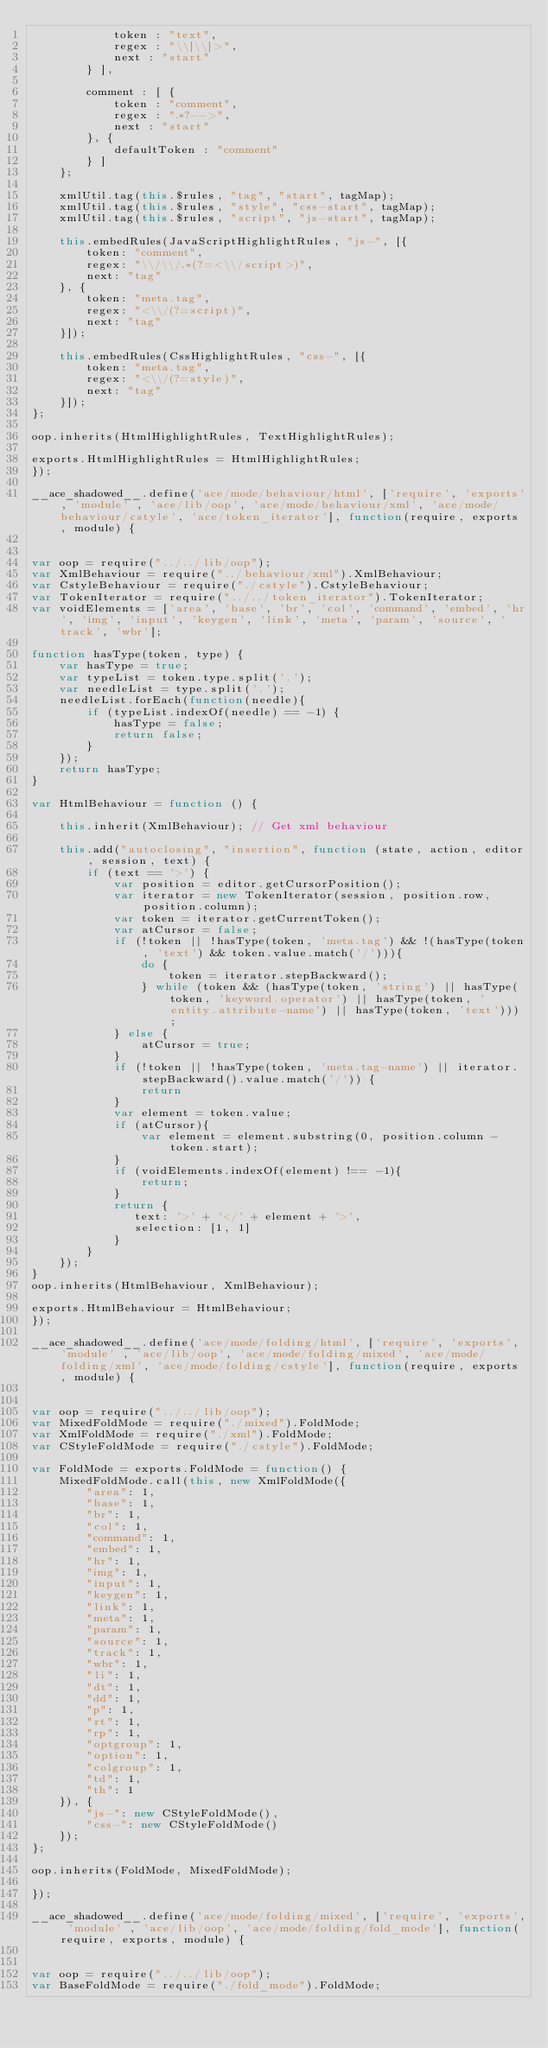Convert code to text. <code><loc_0><loc_0><loc_500><loc_500><_JavaScript_>            token : "text",
            regex : "\\]\\]>",
            next : "start"
        } ],

        comment : [ {
            token : "comment",
            regex : ".*?-->",
            next : "start"
        }, {
            defaultToken : "comment"
        } ]
    };
    
    xmlUtil.tag(this.$rules, "tag", "start", tagMap);
    xmlUtil.tag(this.$rules, "style", "css-start", tagMap);
    xmlUtil.tag(this.$rules, "script", "js-start", tagMap);
    
    this.embedRules(JavaScriptHighlightRules, "js-", [{
        token: "comment",
        regex: "\\/\\/.*(?=<\\/script>)",
        next: "tag"
    }, {
        token: "meta.tag",
        regex: "<\\/(?=script)",
        next: "tag"
    }]);
    
    this.embedRules(CssHighlightRules, "css-", [{
        token: "meta.tag",
        regex: "<\\/(?=style)",
        next: "tag"
    }]);
};

oop.inherits(HtmlHighlightRules, TextHighlightRules);

exports.HtmlHighlightRules = HtmlHighlightRules;
});

__ace_shadowed__.define('ace/mode/behaviour/html', ['require', 'exports', 'module' , 'ace/lib/oop', 'ace/mode/behaviour/xml', 'ace/mode/behaviour/cstyle', 'ace/token_iterator'], function(require, exports, module) {


var oop = require("../../lib/oop");
var XmlBehaviour = require("../behaviour/xml").XmlBehaviour;
var CstyleBehaviour = require("./cstyle").CstyleBehaviour;
var TokenIterator = require("../../token_iterator").TokenIterator;
var voidElements = ['area', 'base', 'br', 'col', 'command', 'embed', 'hr', 'img', 'input', 'keygen', 'link', 'meta', 'param', 'source', 'track', 'wbr'];

function hasType(token, type) {
    var hasType = true;
    var typeList = token.type.split('.');
    var needleList = type.split('.');
    needleList.forEach(function(needle){
        if (typeList.indexOf(needle) == -1) {
            hasType = false;
            return false;
        }
    });
    return hasType;
}

var HtmlBehaviour = function () {

    this.inherit(XmlBehaviour); // Get xml behaviour
    
    this.add("autoclosing", "insertion", function (state, action, editor, session, text) {
        if (text == '>') {
            var position = editor.getCursorPosition();
            var iterator = new TokenIterator(session, position.row, position.column);
            var token = iterator.getCurrentToken();
            var atCursor = false;
            if (!token || !hasType(token, 'meta.tag') && !(hasType(token, 'text') && token.value.match('/'))){
                do {
                    token = iterator.stepBackward();
                } while (token && (hasType(token, 'string') || hasType(token, 'keyword.operator') || hasType(token, 'entity.attribute-name') || hasType(token, 'text')));
            } else {
                atCursor = true;
            }
            if (!token || !hasType(token, 'meta.tag-name') || iterator.stepBackward().value.match('/')) {
                return
            }
            var element = token.value;
            if (atCursor){
                var element = element.substring(0, position.column - token.start);
            }
            if (voidElements.indexOf(element) !== -1){
                return;
            }
            return {
               text: '>' + '</' + element + '>',
               selection: [1, 1]
            }
        }
    });
}
oop.inherits(HtmlBehaviour, XmlBehaviour);

exports.HtmlBehaviour = HtmlBehaviour;
});

__ace_shadowed__.define('ace/mode/folding/html', ['require', 'exports', 'module' , 'ace/lib/oop', 'ace/mode/folding/mixed', 'ace/mode/folding/xml', 'ace/mode/folding/cstyle'], function(require, exports, module) {


var oop = require("../../lib/oop");
var MixedFoldMode = require("./mixed").FoldMode;
var XmlFoldMode = require("./xml").FoldMode;
var CStyleFoldMode = require("./cstyle").FoldMode;

var FoldMode = exports.FoldMode = function() {
    MixedFoldMode.call(this, new XmlFoldMode({
        "area": 1,
        "base": 1,
        "br": 1,
        "col": 1,
        "command": 1,
        "embed": 1,
        "hr": 1,
        "img": 1,
        "input": 1,
        "keygen": 1,
        "link": 1,
        "meta": 1,
        "param": 1,
        "source": 1,
        "track": 1,
        "wbr": 1,
        "li": 1,
        "dt": 1,
        "dd": 1,
        "p": 1,
        "rt": 1,
        "rp": 1,
        "optgroup": 1,
        "option": 1,
        "colgroup": 1,
        "td": 1,
        "th": 1
    }), {
        "js-": new CStyleFoldMode(),
        "css-": new CStyleFoldMode()
    });
};

oop.inherits(FoldMode, MixedFoldMode);

});

__ace_shadowed__.define('ace/mode/folding/mixed', ['require', 'exports', 'module' , 'ace/lib/oop', 'ace/mode/folding/fold_mode'], function(require, exports, module) {


var oop = require("../../lib/oop");
var BaseFoldMode = require("./fold_mode").FoldMode;
</code> 